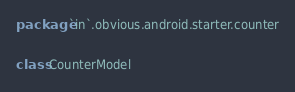<code> <loc_0><loc_0><loc_500><loc_500><_Kotlin_>package `in`.obvious.android.starter.counter

class CounterModel
</code> 